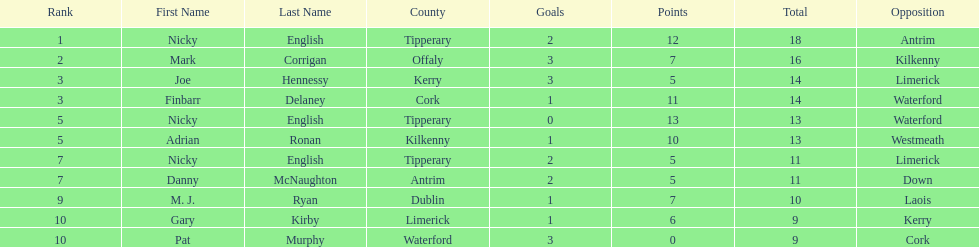Who ranked above mark corrigan? Nicky English. 